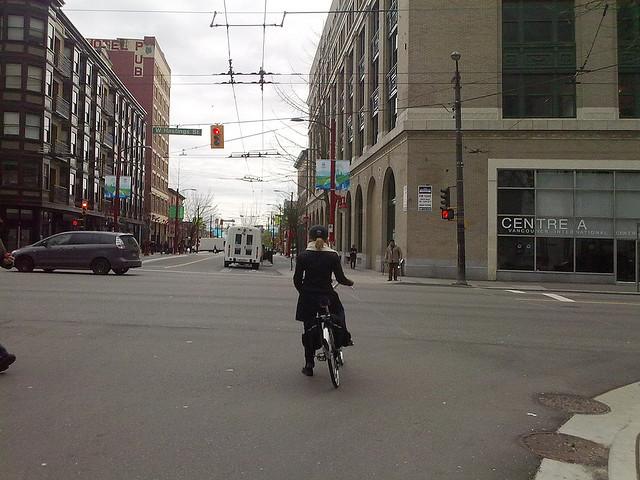How many stop lights are visible?
Keep it brief. 3. What does the window on the right say?
Write a very short answer. Center a. What is this person riding?
Be succinct. Bike. Is the man skating?
Short answer required. No. Is the light green?
Answer briefly. No. What is this man doing?
Give a very brief answer. Riding bike. Is the man riding a motorcycle?
Write a very short answer. No. Is it still raining?
Short answer required. No. How many people are riding a bicycle?
Give a very brief answer. 1. Is the person riding a bike?
Write a very short answer. Yes. What sport is presented?
Short answer required. Biking. How old is the person on the back of the bike?
Keep it brief. 25. Is the traffic signal in disrepair?
Be succinct. No. Is this signal hanging on a wire?
Give a very brief answer. Yes. How many people are shown?
Short answer required. 1. 